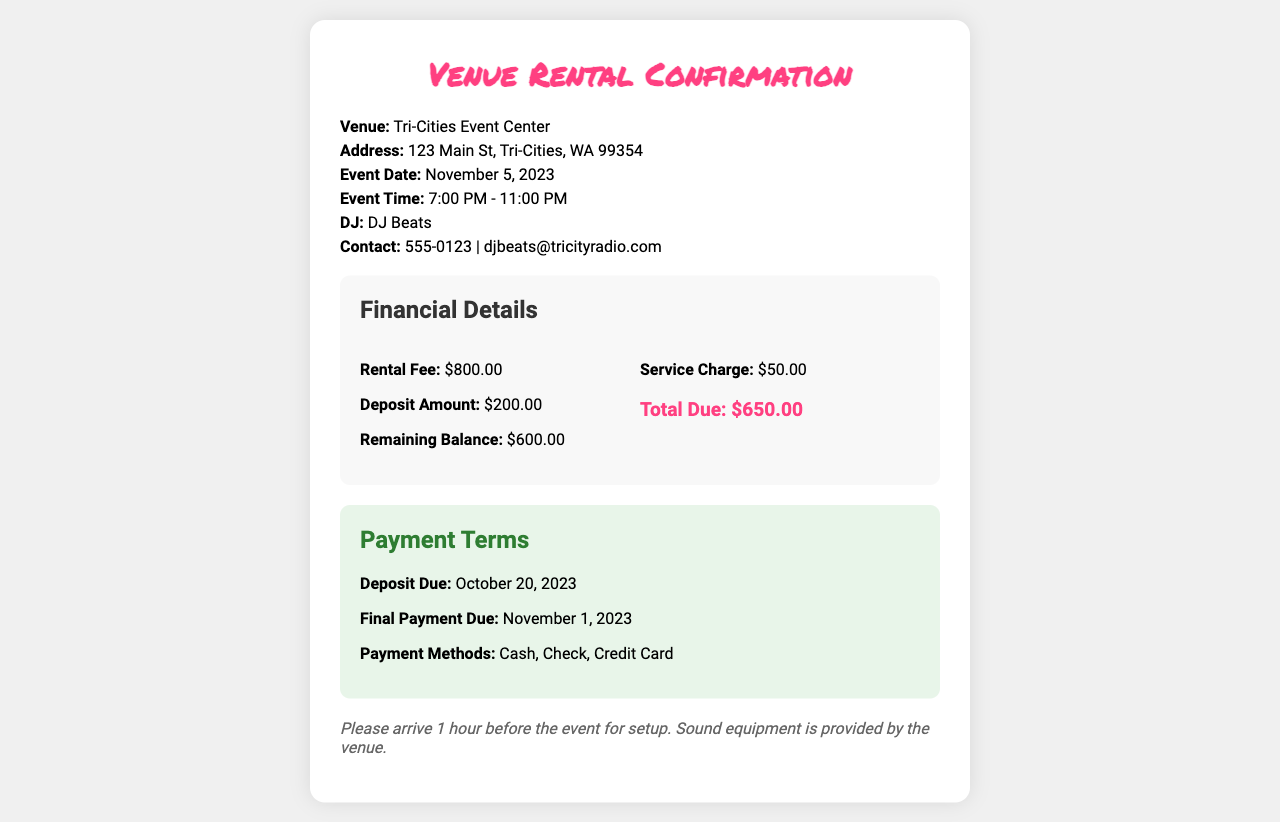What is the venue name? The venue name is explicitly stated in the document as "Tri-Cities Event Center."
Answer: Tri-Cities Event Center What is the rental fee? The rental fee is specifically listed in the financial details section of the document as $800.00.
Answer: $800.00 What is the deposit amount? The deposit amount is provided as $200.00 in the financial details.
Answer: $200.00 When is the deposit due? The document indicates that the deposit due date is October 20, 2023.
Answer: October 20, 2023 What is the total due after all fees? The total due is calculated as $650.00 and is stated in the financial section as Total Due.
Answer: $650.00 What is the final payment due date? The document specifies that the final payment is due on November 1, 2023.
Answer: November 1, 2023 What is included in the payment methods? The payment methods are listed as Cash, Check, and Credit Card.
Answer: Cash, Check, Credit Card What time does the event end? The event time section indicates that the event ends at 11:00 PM.
Answer: 11:00 PM 